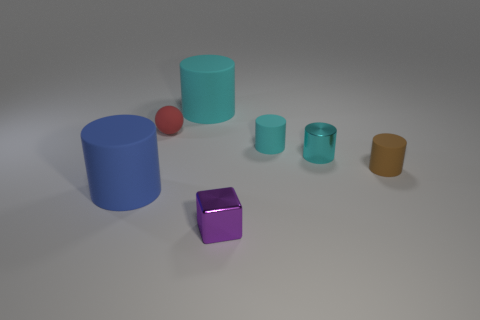There is a cube; does it have the same size as the brown thing behind the metal cube?
Provide a short and direct response. Yes. Is there a tiny purple metal thing behind the tiny rubber thing that is on the right side of the cyan rubber object right of the small metal cube?
Keep it short and to the point. No. What is the material of the big object to the right of the large blue cylinder?
Your response must be concise. Rubber. Do the cyan shiny cylinder and the brown rubber cylinder have the same size?
Make the answer very short. Yes. There is a matte cylinder that is behind the small brown object and on the right side of the small purple object; what is its color?
Provide a short and direct response. Cyan. There is another large object that is made of the same material as the large cyan thing; what is its shape?
Give a very brief answer. Cylinder. How many cyan cylinders are both behind the metallic cylinder and in front of the red rubber ball?
Your response must be concise. 1. Are there any small purple metallic objects on the right side of the cyan metallic object?
Give a very brief answer. No. There is a cyan matte object behind the small ball; is its shape the same as the brown rubber object that is on the right side of the small red thing?
Give a very brief answer. Yes. What number of things are metal cubes or rubber cylinders to the left of the small shiny cylinder?
Provide a short and direct response. 4. 